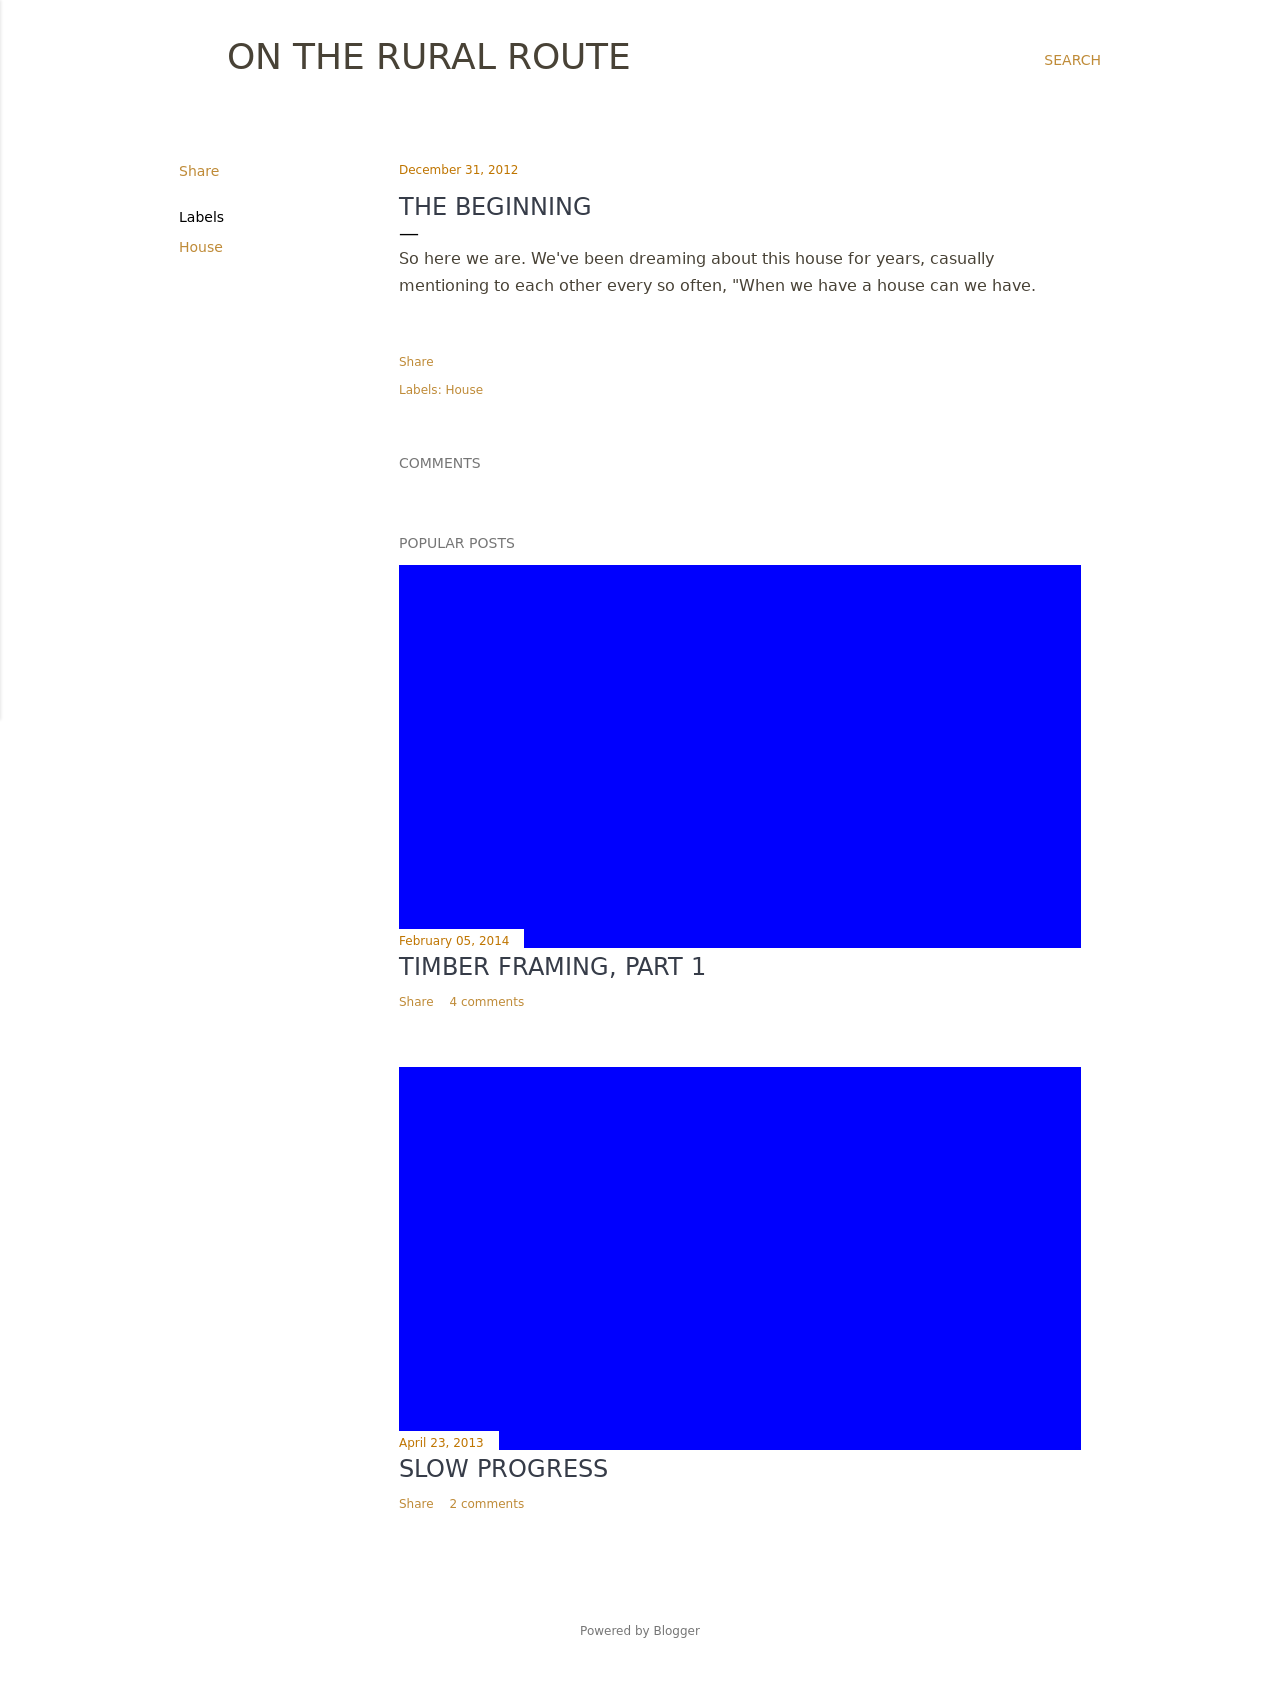What would be an ideal font choice for the titles in the blog entries to keep them elegant yet readable? For a clear and elegant look consistent with the blog's style, consider using serif fonts like 'Merriweather' or 'Playfair Display'. These fonts provide a touch of sophistication while being quite legible, making them perfect for titles and headers in a predominantly text-driven layout. 